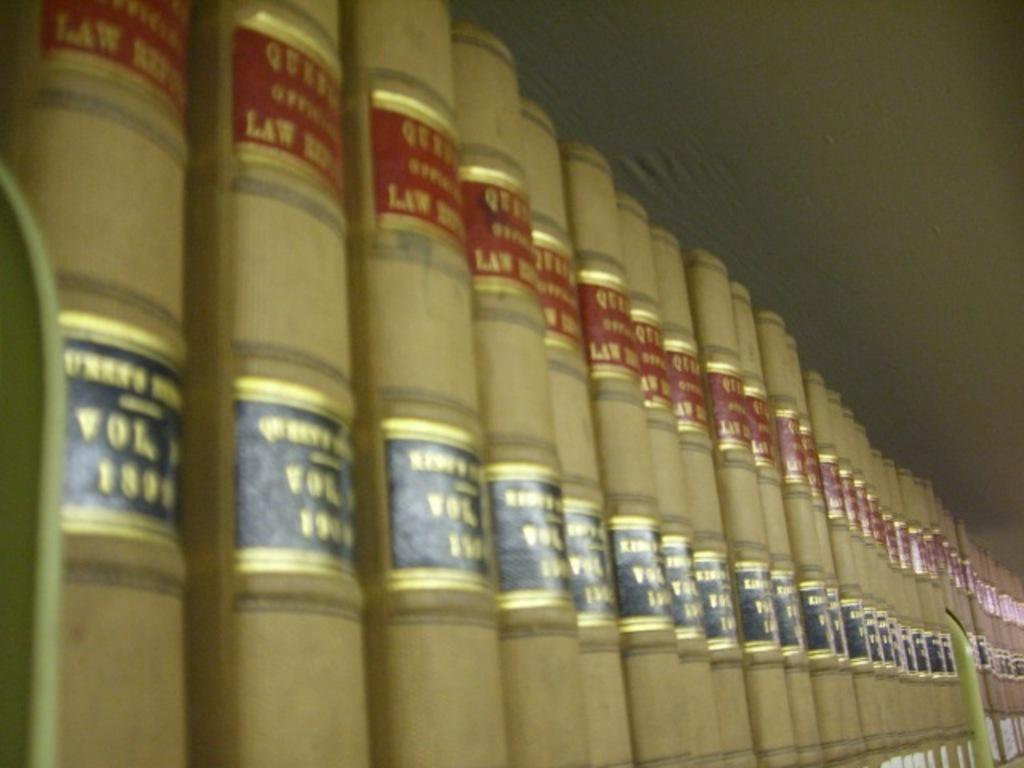<image>
Create a compact narrative representing the image presented. A collection of law books stacked in a row. 